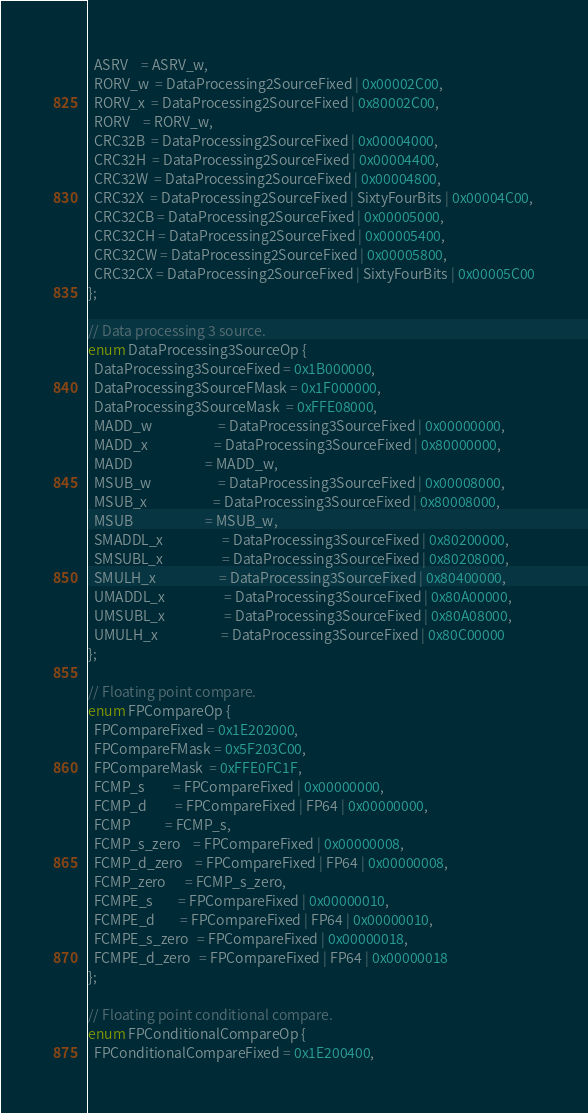<code> <loc_0><loc_0><loc_500><loc_500><_C_>  ASRV    = ASRV_w,
  RORV_w  = DataProcessing2SourceFixed | 0x00002C00,
  RORV_x  = DataProcessing2SourceFixed | 0x80002C00,
  RORV    = RORV_w,
  CRC32B  = DataProcessing2SourceFixed | 0x00004000,
  CRC32H  = DataProcessing2SourceFixed | 0x00004400,
  CRC32W  = DataProcessing2SourceFixed | 0x00004800,
  CRC32X  = DataProcessing2SourceFixed | SixtyFourBits | 0x00004C00,
  CRC32CB = DataProcessing2SourceFixed | 0x00005000,
  CRC32CH = DataProcessing2SourceFixed | 0x00005400,
  CRC32CW = DataProcessing2SourceFixed | 0x00005800,
  CRC32CX = DataProcessing2SourceFixed | SixtyFourBits | 0x00005C00
};

// Data processing 3 source.
enum DataProcessing3SourceOp {
  DataProcessing3SourceFixed = 0x1B000000,
  DataProcessing3SourceFMask = 0x1F000000,
  DataProcessing3SourceMask  = 0xFFE08000,
  MADD_w                     = DataProcessing3SourceFixed | 0x00000000,
  MADD_x                     = DataProcessing3SourceFixed | 0x80000000,
  MADD                       = MADD_w,
  MSUB_w                     = DataProcessing3SourceFixed | 0x00008000,
  MSUB_x                     = DataProcessing3SourceFixed | 0x80008000,
  MSUB                       = MSUB_w,
  SMADDL_x                   = DataProcessing3SourceFixed | 0x80200000,
  SMSUBL_x                   = DataProcessing3SourceFixed | 0x80208000,
  SMULH_x                    = DataProcessing3SourceFixed | 0x80400000,
  UMADDL_x                   = DataProcessing3SourceFixed | 0x80A00000,
  UMSUBL_x                   = DataProcessing3SourceFixed | 0x80A08000,
  UMULH_x                    = DataProcessing3SourceFixed | 0x80C00000
};

// Floating point compare.
enum FPCompareOp {
  FPCompareFixed = 0x1E202000,
  FPCompareFMask = 0x5F203C00,
  FPCompareMask  = 0xFFE0FC1F,
  FCMP_s         = FPCompareFixed | 0x00000000,
  FCMP_d         = FPCompareFixed | FP64 | 0x00000000,
  FCMP           = FCMP_s,
  FCMP_s_zero    = FPCompareFixed | 0x00000008,
  FCMP_d_zero    = FPCompareFixed | FP64 | 0x00000008,
  FCMP_zero      = FCMP_s_zero,
  FCMPE_s        = FPCompareFixed | 0x00000010,
  FCMPE_d        = FPCompareFixed | FP64 | 0x00000010,
  FCMPE_s_zero   = FPCompareFixed | 0x00000018,
  FCMPE_d_zero   = FPCompareFixed | FP64 | 0x00000018
};

// Floating point conditional compare.
enum FPConditionalCompareOp {
  FPConditionalCompareFixed = 0x1E200400,</code> 